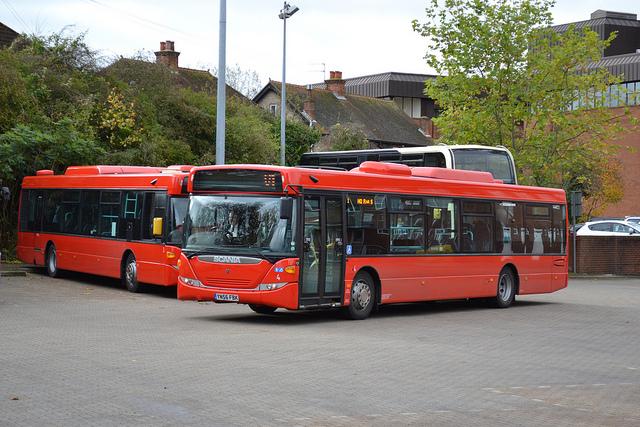How many buses are immediately seen?
Answer briefly. 3. Is anyone boarding the buses?
Quick response, please. No. What color is the bus?
Quick response, please. Red. How many buses are under the overhang?
Be succinct. 3. 